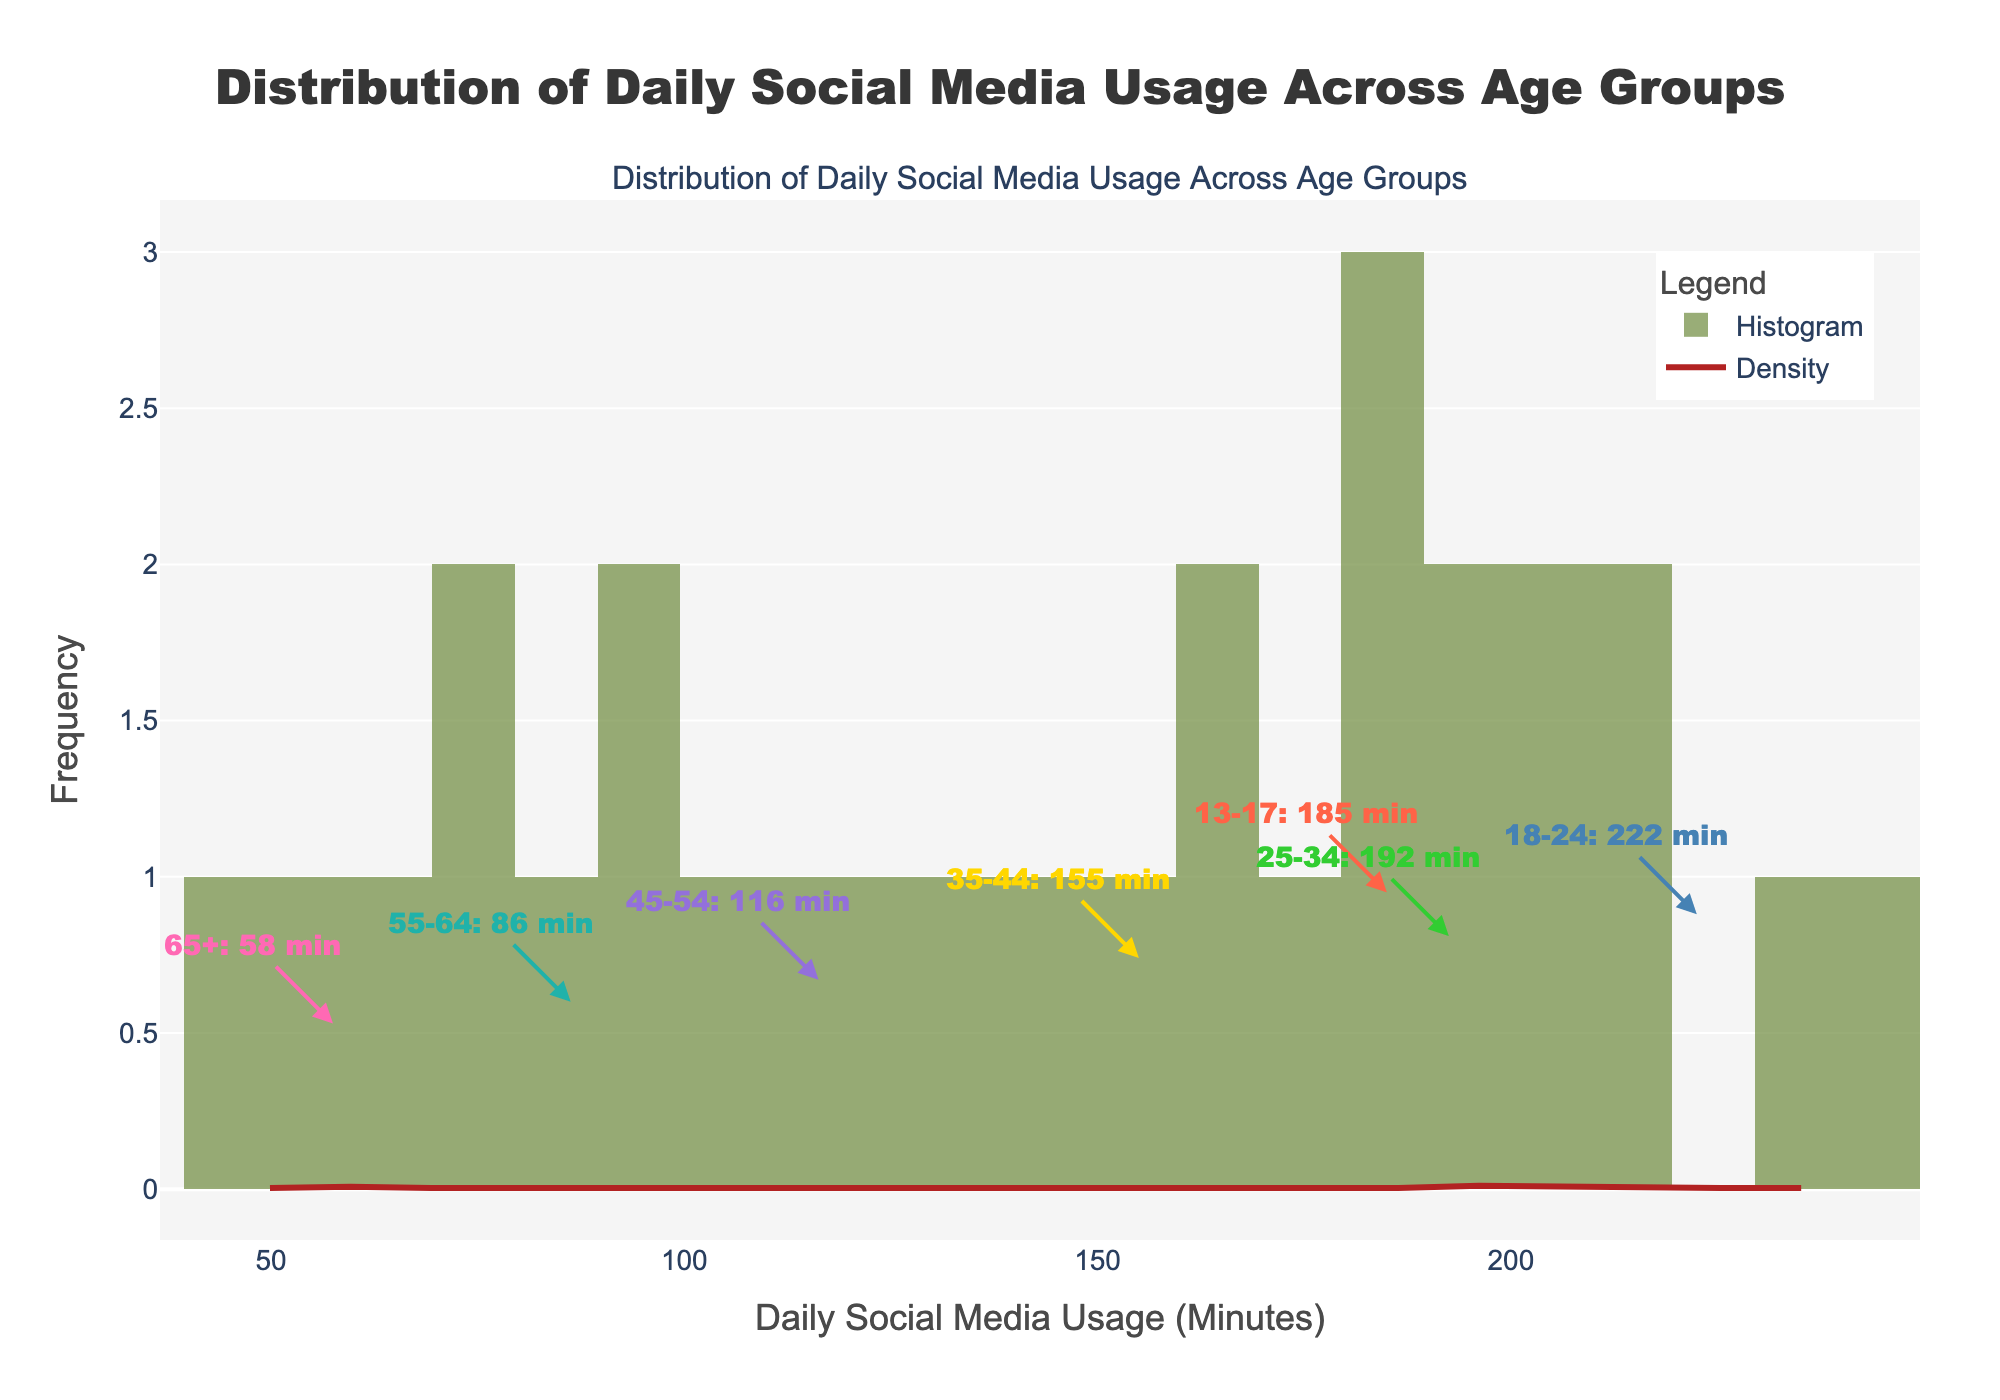What is the title of the figure? The title is located at the top center of the figure. It reads **'Distribution of Daily Social Media Usage Across Age Groups'**.
Answer: Distribution of Daily Social Media Usage Across Age Groups What does the x-axis represent? The x-axis represents the **Daily Social Media Usage (Minutes)**, which shows the number of minutes spent on social media each day.
Answer: Daily Social Media Usage (Minutes) What does the y-axis represent? The y-axis represents the **Frequency**, which indicates how often certain values of daily social media usage (in minutes) occur in the data.
Answer: Frequency Which age group has the highest average daily social media usage? Annotations on the figure display average daily social media usage for each age group. The **18-24** age group has the highest value displayed.
Answer: 18-24 Compare the average daily social media usage between the youngest (13-17) and oldest (65+) age groups. By examining the annotations, the average daily social media usage for the **13-17** age group is **185 minutes**, whereas for the **65+** age group, it is **57.5 minutes**. The difference is calculated as 185 - 57.5 = 127.5 minutes.
Answer: 127.5 minutes What is the average value of daily social media usage across all age groups? To find the average, sum the average values for each age group (185, 222.5, 192.5, 155, 116.25, 86.25, 57.5) and divide by the number of age groups: (185 + 222.5 + 192.5 + 155 + 116.25 + 86.25 + 57.5) / 7 = 145.14 minutes.
Answer: 145.14 minutes Which age group spends less time on social media compared to the age group of 35-44? The average daily usage for the **35-44** age group is **155 minutes**. All groups with averages lower than 155 minutes are **45-54**, **55-64**, and **65+**.
Answer: 45-54, 55-64, 65+ What does the KDE curve (density curve) represent in the figure? The KDE curve represents the **probability density** of daily social media usage over different minutes. It shows how the distribution of usage is spread over the range.
Answer: Probability density How does the frequency peak of the histogram correspond to the KDE peak? The highest peak in the histogram corresponds to the highest peak in the KDE plot, which indicates the most common range of daily social media usage. Both peaks coincide at around **200 minutes** of usage.
Answer: Around 200 minutes 